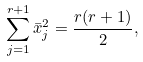<formula> <loc_0><loc_0><loc_500><loc_500>\sum _ { j = 1 } ^ { r + 1 } \bar { x } _ { j } ^ { 2 } = \frac { r ( r + 1 ) } { 2 } ,</formula> 